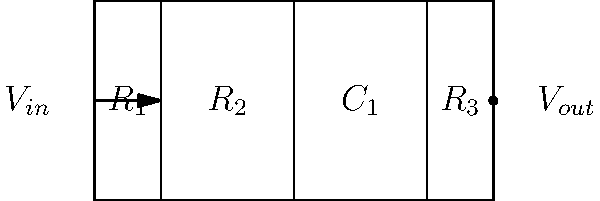In the given circuit diagram, if $R_1 = 1k\Omega$, $R_2 = 2k\Omega$, $R_3 = 3k\Omega$, and $C_1 = 10\mu F$, what is the cutoff frequency of this low-pass filter in Hz? Round your answer to the nearest whole number. To find the cutoff frequency of this low-pass filter, we'll follow these steps:

1) First, we need to identify the components that determine the cutoff frequency. In this case, it's $R_2$ and $C_1$.

2) The formula for the cutoff frequency of a low-pass RC filter is:

   $f_c = \frac{1}{2\pi RC}$

3) We're given that $R_2 = 2k\Omega = 2000\Omega$ and $C_1 = 10\mu F = 10 \times 10^{-6} F$

4) Let's substitute these values into our formula:

   $f_c = \frac{1}{2\pi (2000)(10 \times 10^{-6})}$

5) Simplify:
   
   $f_c = \frac{1}{4\pi \times 10^{-2}}$

6) Calculate:
   
   $f_c \approx 7957.75$ Hz

7) Rounding to the nearest whole number:

   $f_c \approx 7958$ Hz

This cutoff frequency represents the point at which the output signal's power is half of the input signal's power, or where the output voltage is about 70.7% of the input voltage.
Answer: 7958 Hz 